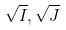<formula> <loc_0><loc_0><loc_500><loc_500>\sqrt { I } , \sqrt { J }</formula> 